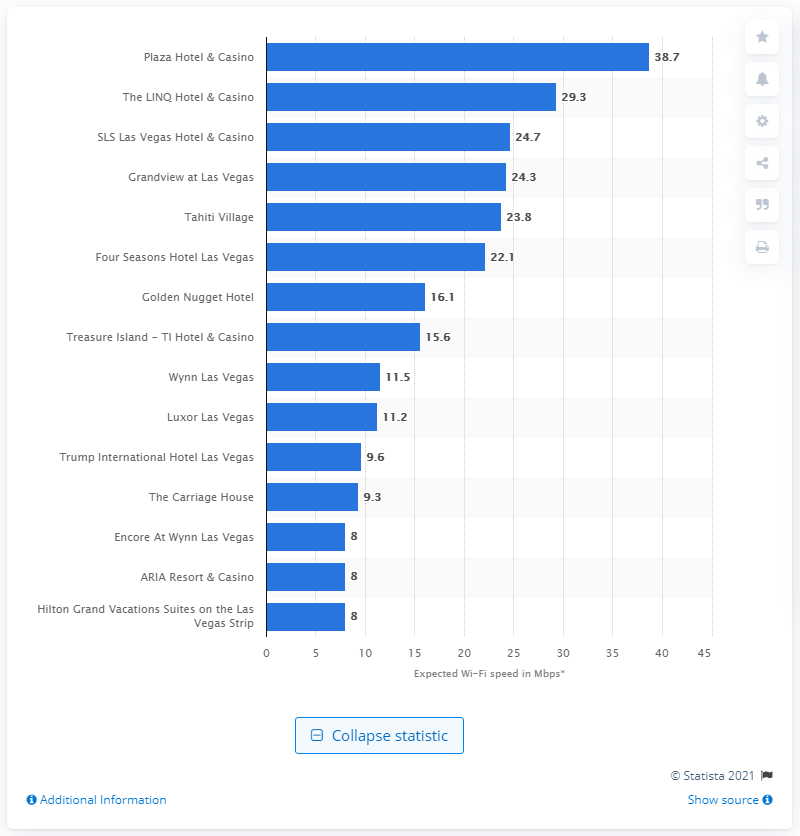Point out several critical features in this image. As of August 2017, the Plaza Hotel & Casino in Las Vegas had the fastest Wi-Fi out of all the hotels in the city. 